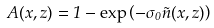<formula> <loc_0><loc_0><loc_500><loc_500>A ( x , z ) = 1 - \exp \left ( - \sigma _ { 0 } \tilde { n } ( x , z ) \right )</formula> 